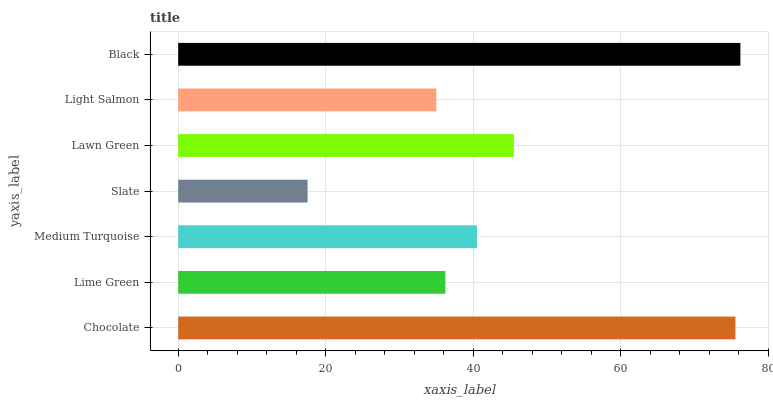Is Slate the minimum?
Answer yes or no. Yes. Is Black the maximum?
Answer yes or no. Yes. Is Lime Green the minimum?
Answer yes or no. No. Is Lime Green the maximum?
Answer yes or no. No. Is Chocolate greater than Lime Green?
Answer yes or no. Yes. Is Lime Green less than Chocolate?
Answer yes or no. Yes. Is Lime Green greater than Chocolate?
Answer yes or no. No. Is Chocolate less than Lime Green?
Answer yes or no. No. Is Medium Turquoise the high median?
Answer yes or no. Yes. Is Medium Turquoise the low median?
Answer yes or no. Yes. Is Slate the high median?
Answer yes or no. No. Is Lawn Green the low median?
Answer yes or no. No. 